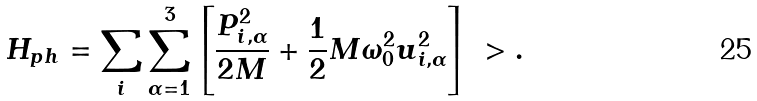Convert formula to latex. <formula><loc_0><loc_0><loc_500><loc_500>H _ { p h } = \sum _ { i } \sum _ { \alpha = 1 } ^ { 3 } \left [ \frac { P ^ { 2 } _ { i , \alpha } } { 2 M } + \frac { 1 } { 2 } M \omega _ { 0 } ^ { 2 } u _ { i , \alpha } ^ { 2 } \right ] \ > .</formula> 